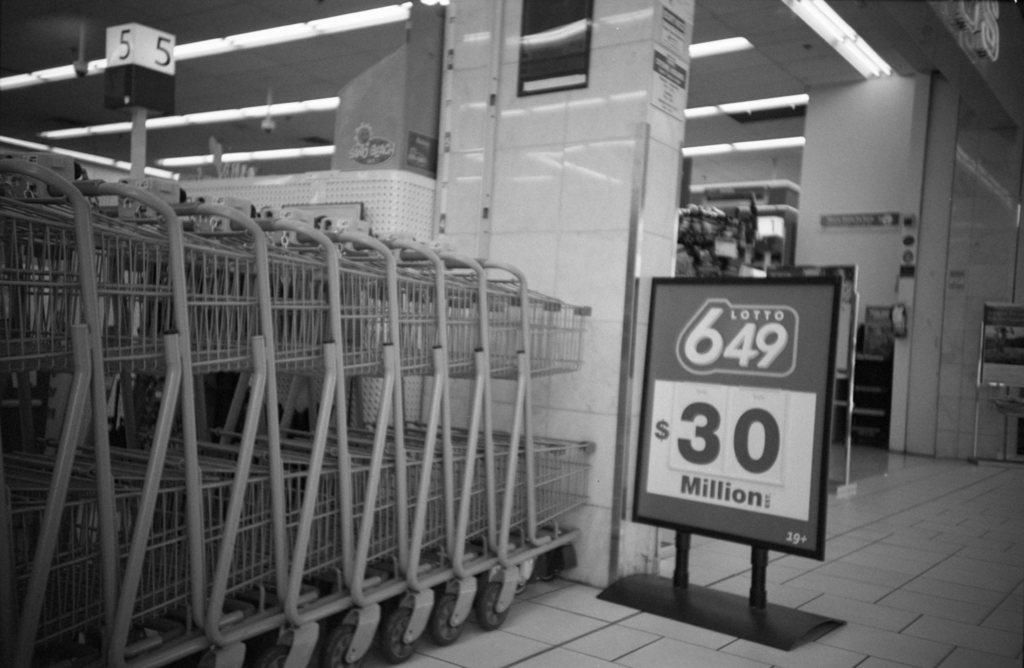<image>
Present a compact description of the photo's key features. A super market aisle has the sign with the words $30 million on it next to a series of carts. 